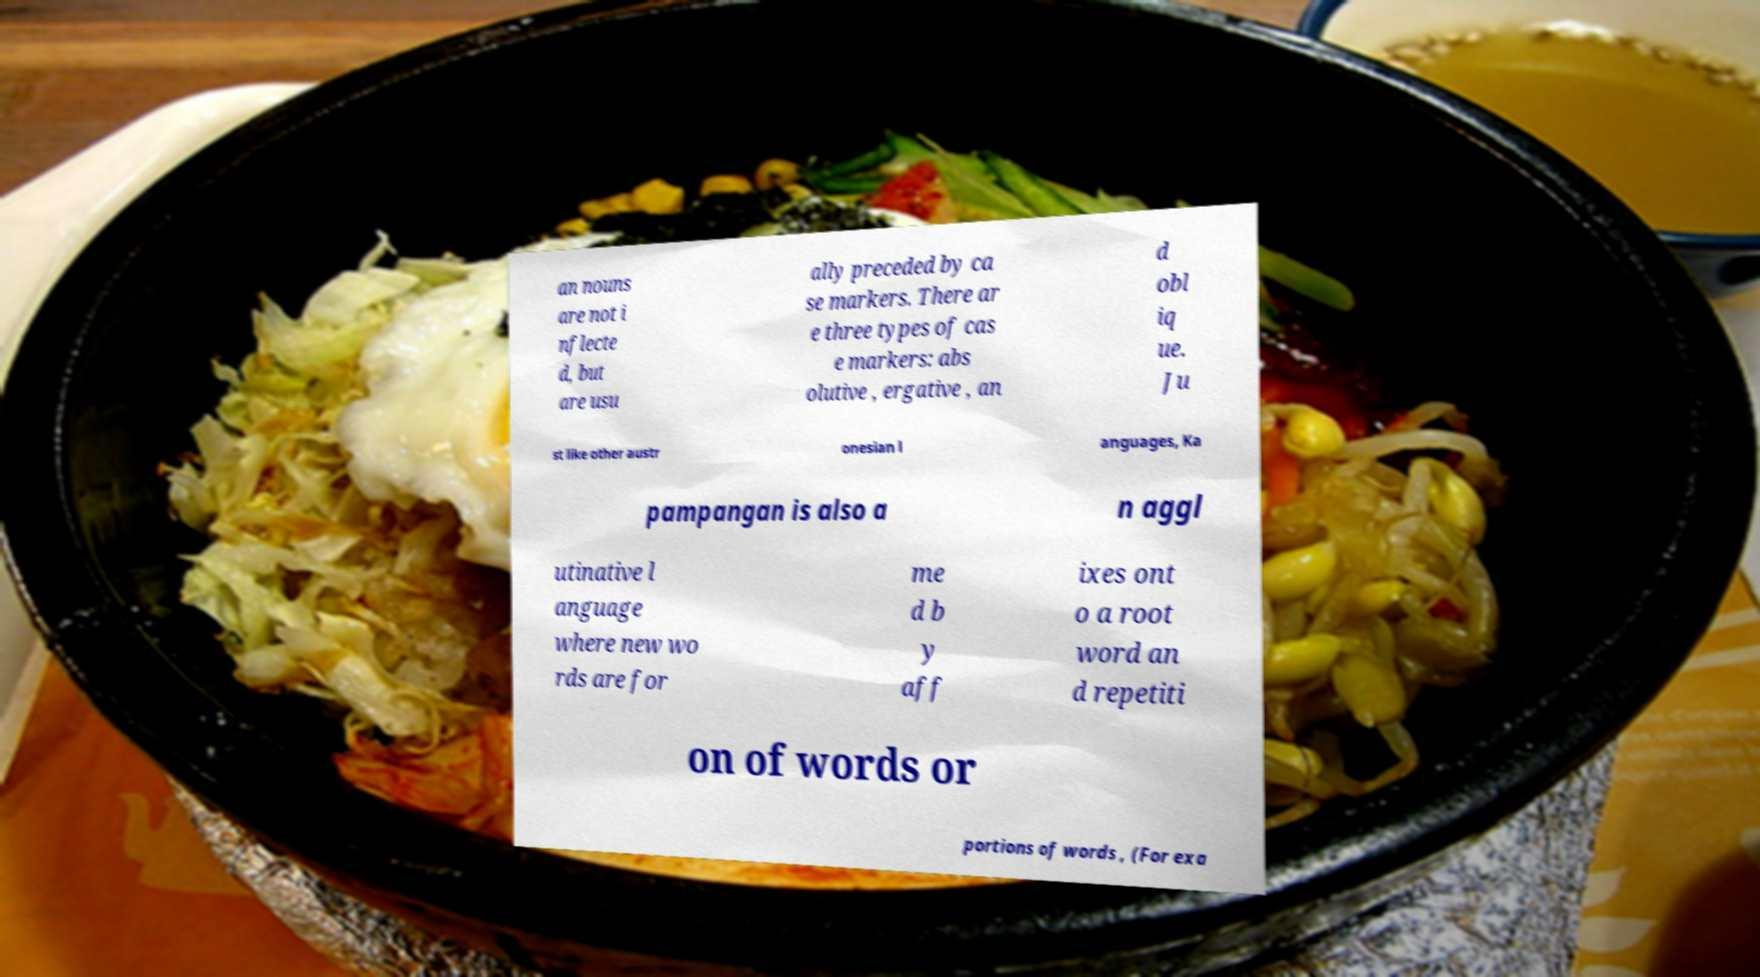Please read and relay the text visible in this image. What does it say? an nouns are not i nflecte d, but are usu ally preceded by ca se markers. There ar e three types of cas e markers: abs olutive , ergative , an d obl iq ue. Ju st like other austr onesian l anguages, Ka pampangan is also a n aggl utinative l anguage where new wo rds are for me d b y aff ixes ont o a root word an d repetiti on of words or portions of words , (For exa 